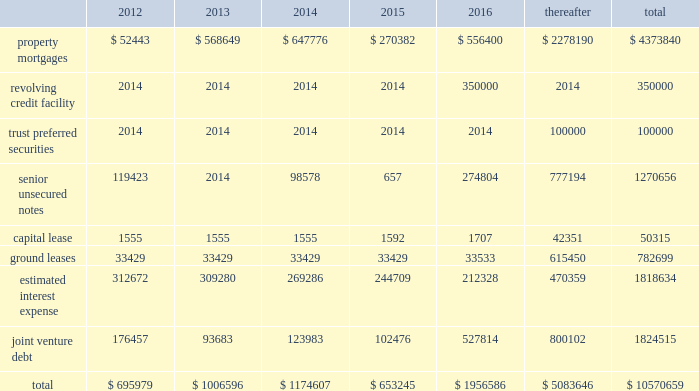56 / 57 management 2019s discussion and analysis of financial condition and results of operations junior subordinate deferrable interest debentures in june 2005 , we issued $ 100.0 a0million of trust preferred securities , which are reflected on the balance sheet as junior subordinate deferrable interest debentures .
The proceeds were used to repay our revolving credit facility .
The $ 100.0 a0million of junior subordi- nate deferrable interest debentures have a 30-year term ending july 2035 .
They bear interest at a fixed rate of 5.61% ( 5.61 % ) for the first 10 years ending july 2015 .
Thereafter , the rate will float at three month libor plus 1.25% ( 1.25 % ) .
The securities are redeemable at par .
Restrictive covenants the terms of the 2011 revolving credit facility and certain of our senior unsecured notes include certain restrictions and covenants which may limit , among other things , our ability to pay dividends ( as discussed below ) , make certain types of investments , incur additional indebtedness , incur liens and enter into negative pledge agreements and the disposition of assets , and which require compliance with financial ratios including our minimum tangible net worth , a maximum ratio of total indebtedness to total asset value , a minimum ratio of ebitda to fixed charges and a maximum ratio of unsecured indebtedness to unencumbered asset value .
The dividend restriction referred to above provides that we will not during any time when we are in default , make distributions with respect to common stock or other equity interests , except to enable us to continue to qualify as a reit for federal income tax purposes .
As of december a031 , 2011 and 2010 , we were in compli- ance with all such covenants .
Market rate risk we are exposed to changes in interest rates primarily from our floating rate borrowing arrangements .
We use interest rate deriv- ative instruments to manage exposure to interest rate changes .
A a0hypothetical 100 a0basis point increase in interest rates along the entire interest rate curve for 2011 and 2010 , would increase our annual interest cost by approximately $ 12.3 a0million and $ 11.0 a0mil- lion and would increase our share of joint venture annual interest cost by approximately $ 4.8 a0million and $ 6.7 a0million , respectively .
We recognize all derivatives on the balance sheet at fair value .
Derivatives that are not hedges must be adjusted to fair value through income .
If a derivative is a hedge , depending on the nature of the hedge , changes in the fair value of the derivative will either be offset against the change in fair value of the hedged asset , liability , or firm commitment through earnings , or recognized in other comprehensive income until the hedged item is recognized in earnings .
The ineffective portion of a derivative 2019s change in fair value is recognized immediately in earnings .
Approximately $ 4.8 a0billion of our long- term debt bore interest a0at fixed rates , and therefore the fair value of these instru- ments is affected by changes in the market interest rates .
The interest rate on our variable rate debt and joint venture debt as of december a031 , 2011 ranged from libor plus 150 a0basis points to libor plus 350 a0basis points .
Contractual obligations combined aggregate principal maturities of mortgages and other loans payable , our 2011 revolving credit facility , senior unsecured notes ( net of discount ) , trust preferred securities , our share of joint venture debt , including as- of-right extension options , estimated interest expense ( based on weighted average interest rates for the quarter ) , and our obligations under our capital lease and ground leases , as of december a031 , 2011 are as follows ( in thousands ) : .

What was the change in ground leases between 2012 and 2013 in millions? 
Computations: (33429 - 33429)
Answer: 0.0. 